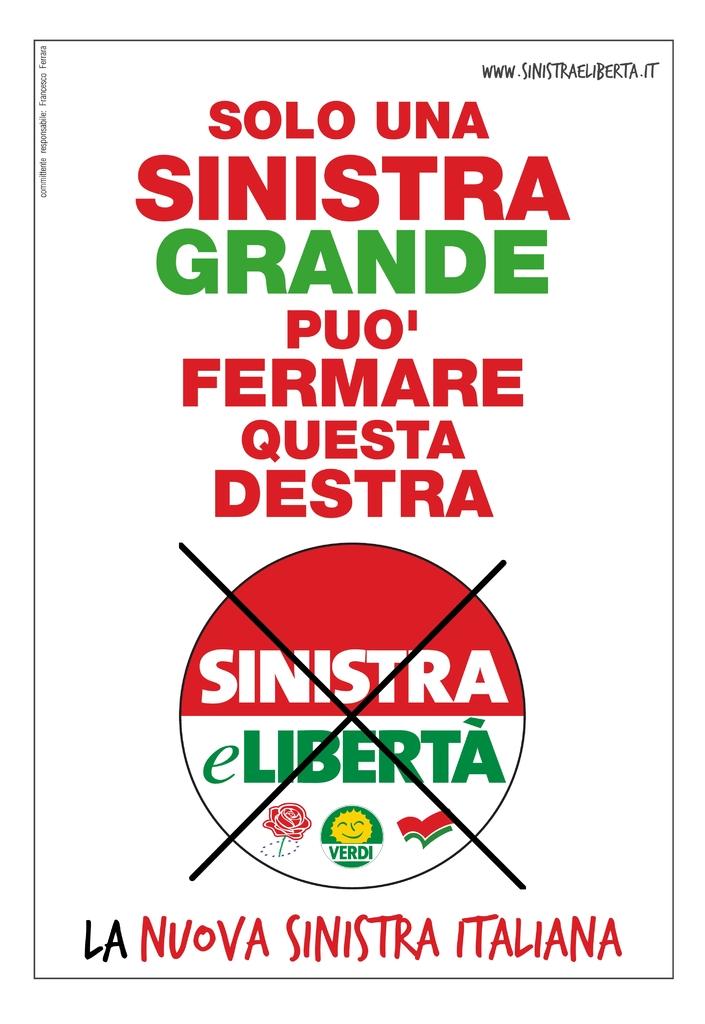What is their website?
Give a very brief answer. Www.sinistraeliberta.it. What country is shown on the bottom of the poster?
Offer a terse response. Italiana. 